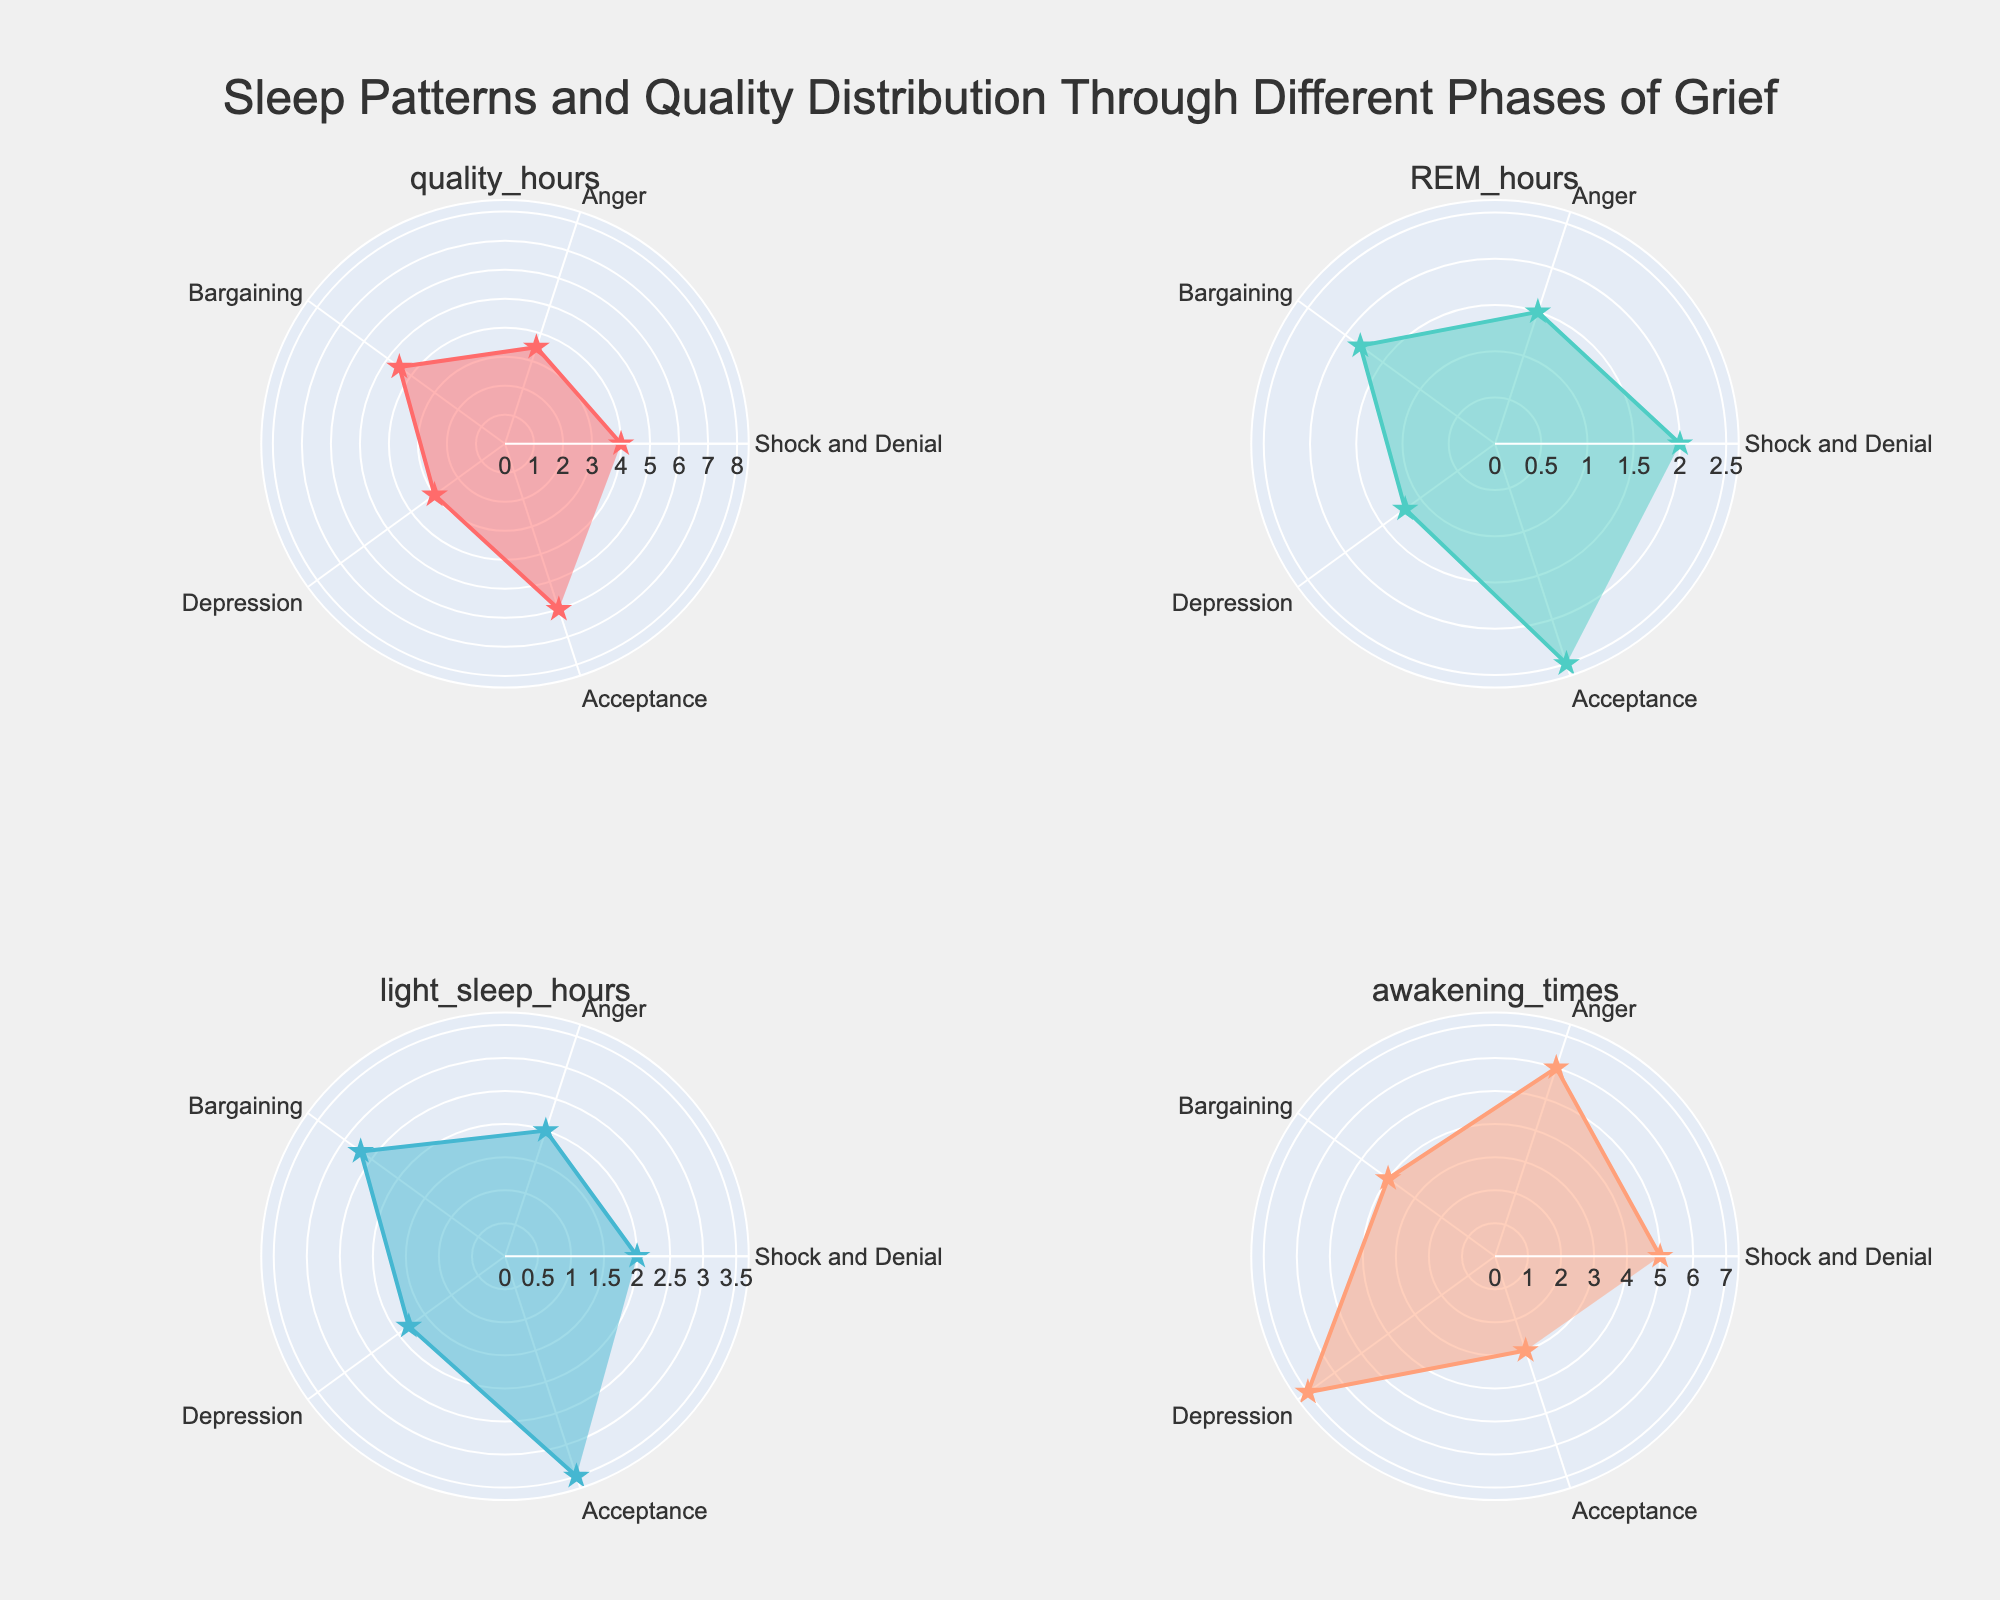How many phases of grief are represented in the figure? There are five distinct phases in the figure: Shock and Denial, Anger, Bargaining, Depression, and Acceptance.
Answer: Five Which phase has the highest quality hours of sleep? By examining the plot for quality hours, the Acceptance phase has the highest value.
Answer: Acceptance In which phase do we see the maximum number of awakening times? Looking at the subplot for awakening times, the Depression phase shows the highest number of awakenings.
Answer: Depression What is the average number of REM hours across all phases? The REM hours for each phase are as follows: 2, 1.5, 1.8, 1.2, 2.5. Summing them gives 9 and dividing by the number of phases (5) gives an average of 1.8.
Answer: 1.8 Which phase shows the lowest amount of light sleep hours? By checking the light sleep hours subplot, the Depression phase has the lowest amount with 1.8 hours.
Answer: Depression How does the Bargaining phase compare to the Anger phase in terms of quality hours and awakening times? The Bargaining phase has 4.5 quality hours and 4 awakening times, while the Anger phase has 3.5 quality hours and 6 awakening times. Comparing these values, Bargaining has more quality hours and fewer awakening times.
Answer: Bargaining has more quality hours and fewer awakening times What are the REM and light sleep hours during the Acceptance phase? Acceptance has 2.5 hours of REM sleep and 3.5 hours of light sleep.
Answer: 2.5 REM hours and 3.5 light sleep hours Which phase has the most balanced distribution of light sleep and REM hours? For the most balanced distribution, we look for phases where the REM and light sleep hours are closest. The Shock and Denial phase has 2 REM and 2 light sleep hours, making it the most balanced.
Answer: Shock and Denial If you sum up the quality hours and light sleep hours in the Acceptance phase, what is the total? The quality hours in the Acceptance phase are 6, and light sleep hours are 3.5. Summing these gives a total of 9.5.
Answer: 9.5 Which two phases have a total quality sleep hours difference of 1 or less? Quality sleep hours: Shock and Denial (4), Anger (3.5), Bargaining (4.5), Depression (3), Acceptance (6). Checking differences: Shock and Denial & Bargaining (0.5), Anger & Depression (0.5).
Answer: Shock and Denial & Bargaining, Anger & Depression 